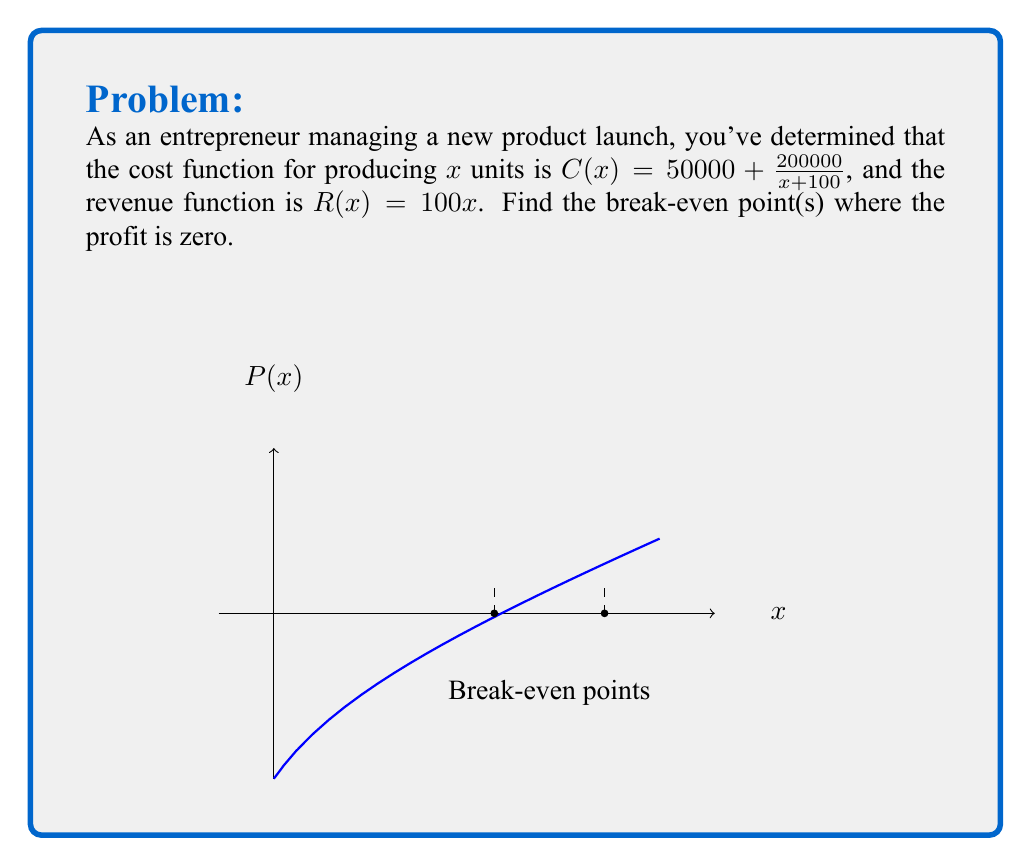Solve this math problem. To find the break-even point(s), we need to solve the equation where profit P(x) = 0:

1) Profit function: $P(x) = R(x) - C(x)$

2) Substitute the given functions:
   $P(x) = 100x - (50000 + \frac{200000}{x + 100})$

3) Set P(x) = 0 and solve:
   $0 = 100x - 50000 - \frac{200000}{x + 100}$

4) Multiply both sides by (x + 100):
   $0 = 100x(x + 100) - 50000(x + 100) - 200000$

5) Expand:
   $0 = 100x^2 + 10000x - 50000x - 5000000 - 200000$
   $0 = 100x^2 - 40000x - 5200000$

6) Rearrange to standard quadratic form:
   $100x^2 - 40000x - 5200000 = 0$

7) Divide by 100:
   $x^2 - 400x - 52000 = 0$

8) Use the quadratic formula: $x = \frac{-b \pm \sqrt{b^2 - 4ac}}{2a}$
   $x = \frac{400 \pm \sqrt{400^2 - 4(1)(-52000)}}{2(1)}$
   $x = \frac{400 \pm \sqrt{160000 + 208000}}{2}$
   $x = \frac{400 \pm \sqrt{368000}}{2}$
   $x = \frac{400 \pm 606.63}{2}$

9) Solve:
   $x_1 = \frac{400 + 606.63}{2} \approx 503.315$
   $x_2 = \frac{400 - 606.63}{2} \approx -103.315$

10) Since x represents units produced, we discard the negative solution.

Therefore, the break-even point occurs at approximately 503 units.
Answer: 503 units 